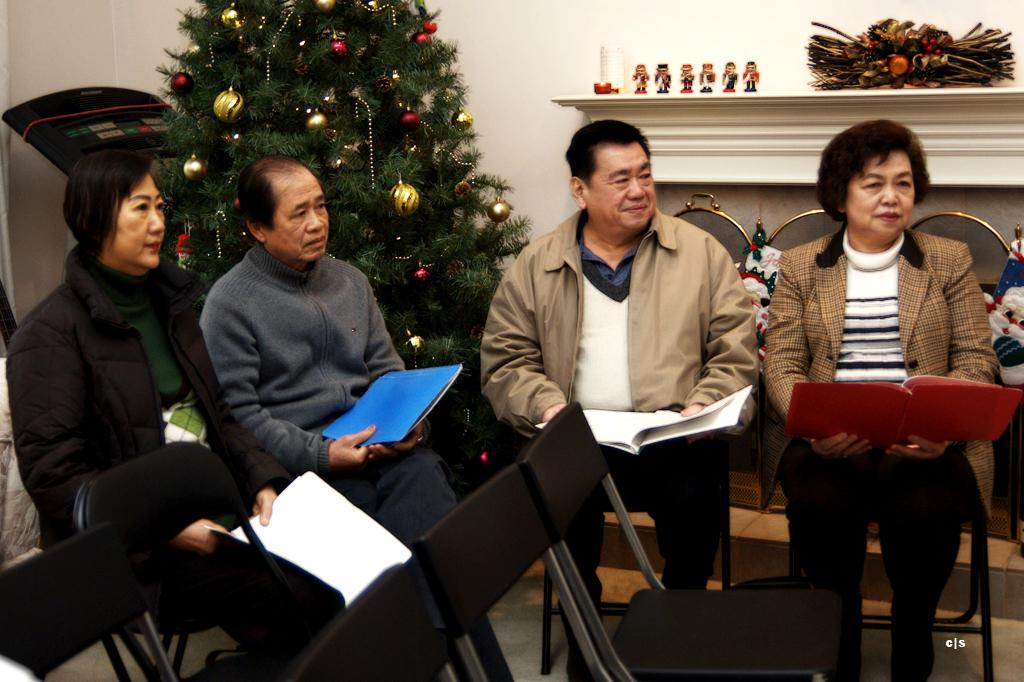What type of wall is visible in the image? There is a white wall in the image. What is the main decoration in the image? There is a Christmas tree in the image. What are the people in the image doing? The people are sitting on chairs and holding files. What else can be seen in the image besides the people and the Christmas tree? There are toys in the image. Can you tell me how many toads are sitting on the chairs with the people in the image? There are no toads present in the image; only people are sitting on the chairs. What type of parent is depicted in the image? There is no parent depicted in the image; the people are holding files, but their roles are not specified. 